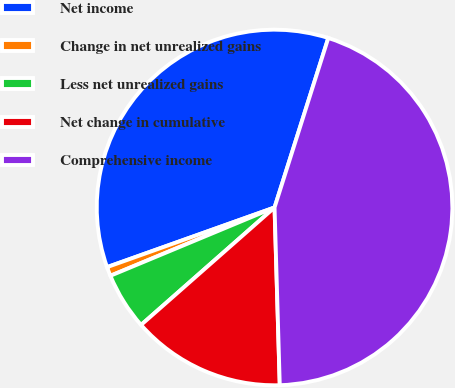Convert chart to OTSL. <chart><loc_0><loc_0><loc_500><loc_500><pie_chart><fcel>Net income<fcel>Change in net unrealized gains<fcel>Less net unrealized gains<fcel>Net change in cumulative<fcel>Comprehensive income<nl><fcel>35.33%<fcel>0.83%<fcel>5.21%<fcel>13.98%<fcel>44.64%<nl></chart> 